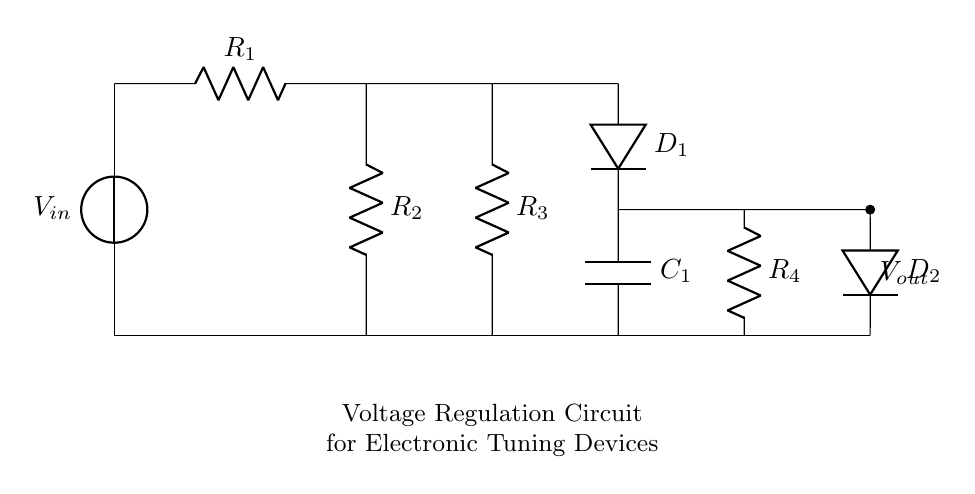What is the main voltage source in the circuit? The main voltage source is labeled as \( V_{in} \) located at the top of the schematic. It provides the input voltage for the circuit.
Answer: \( V_{in} \) How many resistors are in the circuit? There are four resistors in the circuit, indicated by the labels \( R_1, R_2, R_3, \) and \( R_4 \). Each resistor is drawn in sequence, showing distinct connections.
Answer: 4 What does the component \( D_1 \) represent? \( D_1 \) represents a diode, which is commonly used in circuits for controlling the direction of current flow. It is located after the \( R_3 \) resistor.
Answer: Diode What is the purpose of capacitor \( C_1 \)? \( C_1 \) acts as a filtering component, smoothing out fluctuations in voltage and stabilizing the output across the load. It is found below \( D_1 \).
Answer: Filtering What is the output voltage labeled as? The output voltage is labeled as \( V_{out} \), located on the right side of the circuit. It indicates the voltage available at that point in the circuit.
Answer: \( V_{out} \) Calculate the current division through resistors \( R_1 \) and \( R_2 \) if \( R_1 \) is twice the value of \( R_2 \). Applying the current divider rule, if \( R_1 = 2R_2 \), the current through \( R_1 \) will be one-third of the total current while the current through \( R_2 \) will be two-thirds of the total current. This can be derived using the formula: \( I_1 = \frac{R_2}{R_1 + R_2} I_{total} \) and \( I_2 = \frac{R_1}{R_1 + R_2} I_{total} \).
Answer: One-third for \( R_1 \), two-thirds for \( R_2 \) 